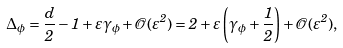Convert formula to latex. <formula><loc_0><loc_0><loc_500><loc_500>\Delta _ { \phi } = \frac { d } { 2 } - 1 + \varepsilon \gamma _ { \phi } + \mathcal { O } ( \varepsilon ^ { 2 } ) = 2 + \varepsilon \left ( \gamma _ { \phi } + \frac { 1 } { 2 } \right ) + \mathcal { O } ( \varepsilon ^ { 2 } ) ,</formula> 